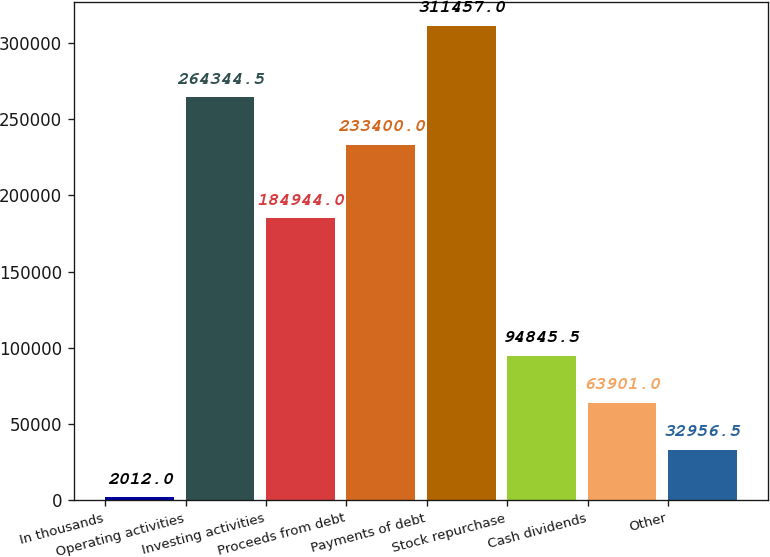Convert chart. <chart><loc_0><loc_0><loc_500><loc_500><bar_chart><fcel>In thousands<fcel>Operating activities<fcel>Investing activities<fcel>Proceeds from debt<fcel>Payments of debt<fcel>Stock repurchase<fcel>Cash dividends<fcel>Other<nl><fcel>2012<fcel>264344<fcel>184944<fcel>233400<fcel>311457<fcel>94845.5<fcel>63901<fcel>32956.5<nl></chart> 